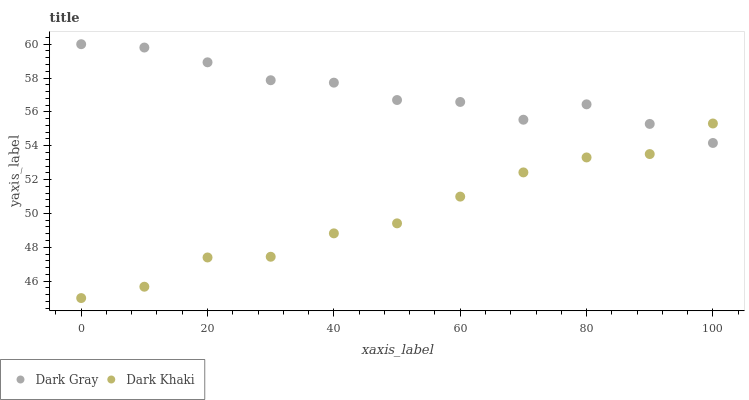Does Dark Khaki have the minimum area under the curve?
Answer yes or no. Yes. Does Dark Gray have the maximum area under the curve?
Answer yes or no. Yes. Does Dark Khaki have the maximum area under the curve?
Answer yes or no. No. Is Dark Gray the smoothest?
Answer yes or no. Yes. Is Dark Khaki the roughest?
Answer yes or no. Yes. Is Dark Khaki the smoothest?
Answer yes or no. No. Does Dark Khaki have the lowest value?
Answer yes or no. Yes. Does Dark Gray have the highest value?
Answer yes or no. Yes. Does Dark Khaki have the highest value?
Answer yes or no. No. Does Dark Gray intersect Dark Khaki?
Answer yes or no. Yes. Is Dark Gray less than Dark Khaki?
Answer yes or no. No. Is Dark Gray greater than Dark Khaki?
Answer yes or no. No. 